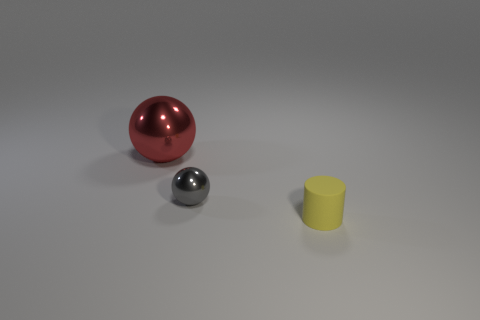Is there any other thing that has the same material as the yellow thing?
Your answer should be very brief. No. Is the number of spheres right of the large red metal thing the same as the number of small gray metallic balls?
Offer a very short reply. Yes. The other matte thing that is the same size as the gray thing is what shape?
Your answer should be compact. Cylinder. Are there any things that are in front of the metal ball in front of the red sphere?
Your response must be concise. Yes. How many large things are either red blocks or gray things?
Ensure brevity in your answer.  0. Are there any things that have the same size as the yellow rubber cylinder?
Give a very brief answer. Yes. What number of shiny things are balls or tiny cylinders?
Provide a succinct answer. 2. How many gray metal things are there?
Give a very brief answer. 1. Is the material of the sphere that is on the right side of the large metal sphere the same as the tiny cylinder that is on the right side of the large red metal ball?
Offer a very short reply. No. The gray thing that is made of the same material as the big sphere is what size?
Your answer should be compact. Small. 